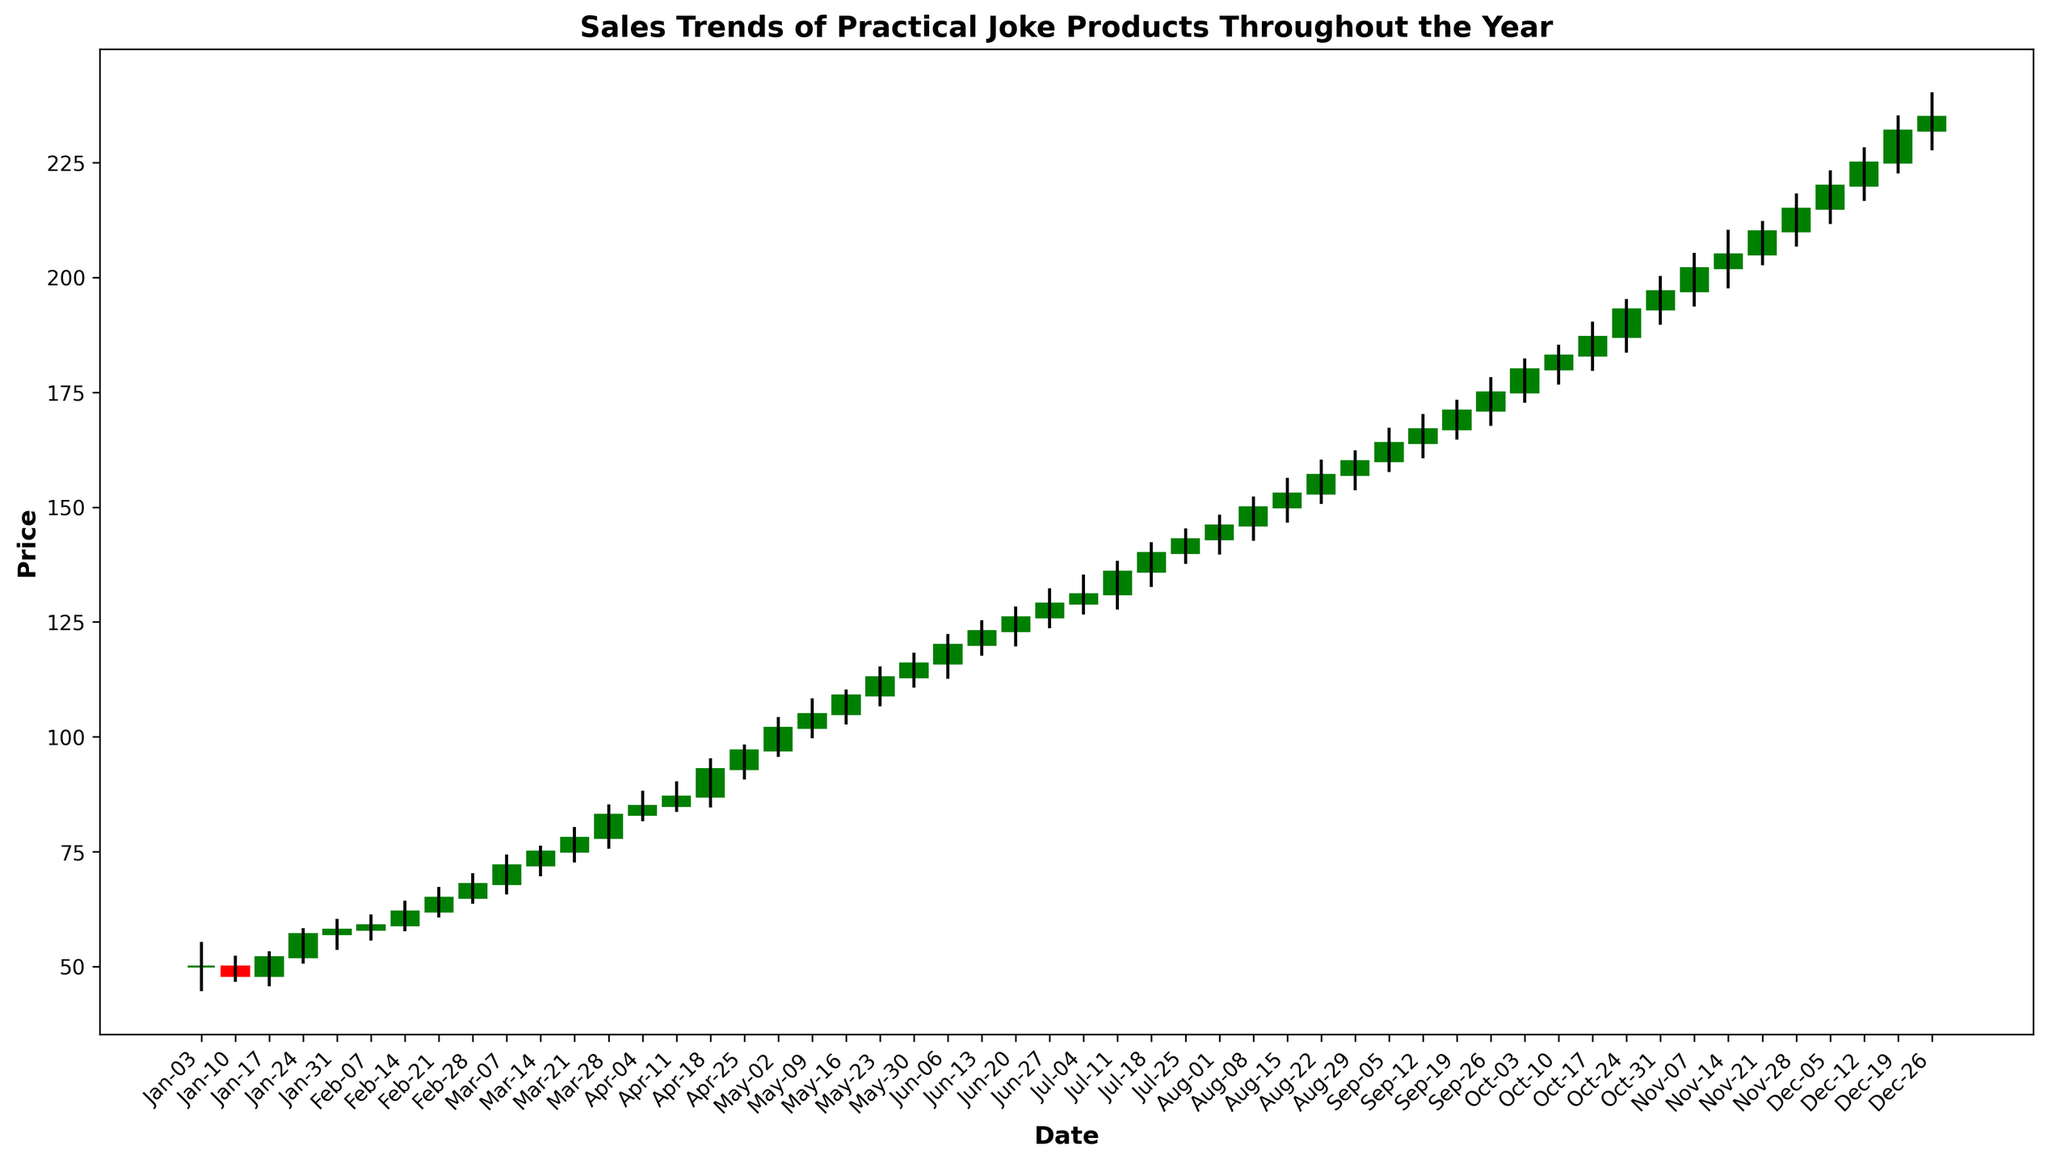What was the highest sales price during the year? The highest price is indicated by the highest top of any candlestick, which occurs in the data for December 19th with a high of 235.
Answer: 235 What was the lowest sales price during the year? The lowest price can be identified by the lowest bottom of any candlestick. This occurs in the data for January 3rd with a low of 45.
Answer: 45 Which month saw the most significant increase in sales prices? To determine this, look for the month where the closing price rose significantly over the opening price. January shows a significant surge, opening at 50 and eventually closing at 58 for the last week.
Answer: January When did the price first close at or above 100? Check the closing prices for each week to find the first instance of 100 or above. This happened on the week starting May 2nd, closing at 102.
Answer: May 2nd During which month did the sales prices remain relatively stable? April shows consistent high and low prices with narrow candlesticks indicating relatively stable prices from opening to closing each week.
Answer: April Which week showed the greatest fluctuation in prices? For the greatest difference between the high and low prices, the week of April 18th stands out, having a high of 95 and a low of 85, displaying a fluctuation of 10 units.
Answer: April 18th What was the closing price at the end of the second quarter? The second quarter ends at the last week of June, so the closing price is for June 27th, which is 129.
Answer: 129 How many months experienced a continuous uptrend without any price drops? Examine the months where each week’s closing price is higher than the previous one. From February to April, the closing prices show a continuous uptrend without any drops.
Answer: 3 months When did the price first exceed 150? The closing price first went above 150 on the week starting August 15th, closing at 153.
Answer: August 15th Compare the opening price of January to the closing price of December, what is the difference? The opening price of January is 50, and the closing price of December is 235. The difference is 235 - 50.
Answer: 185 